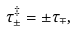<formula> <loc_0><loc_0><loc_500><loc_500>\tau _ { \pm } ^ { \ddagger } = \pm \tau _ { \mp } ,</formula> 